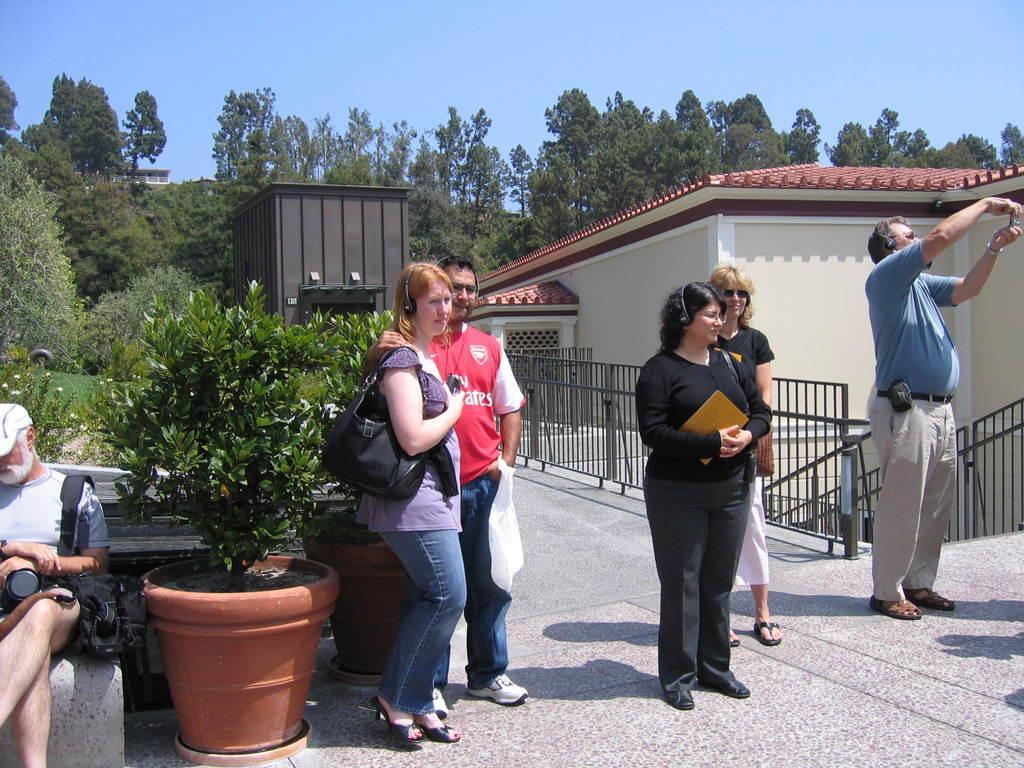How would you summarize this image in a sentence or two? In this image we can see a group of people standing on the ground. One woman is wearing black dress is holding a book in her hand ,one person is holding a camera in his hand. On the left side of the image we can see group of plants placed in containers on the ground. One person is wearing a cap and a bag is sitting on a bench. In the background, we can metal railing, staircase, building, group of trees and sky. 